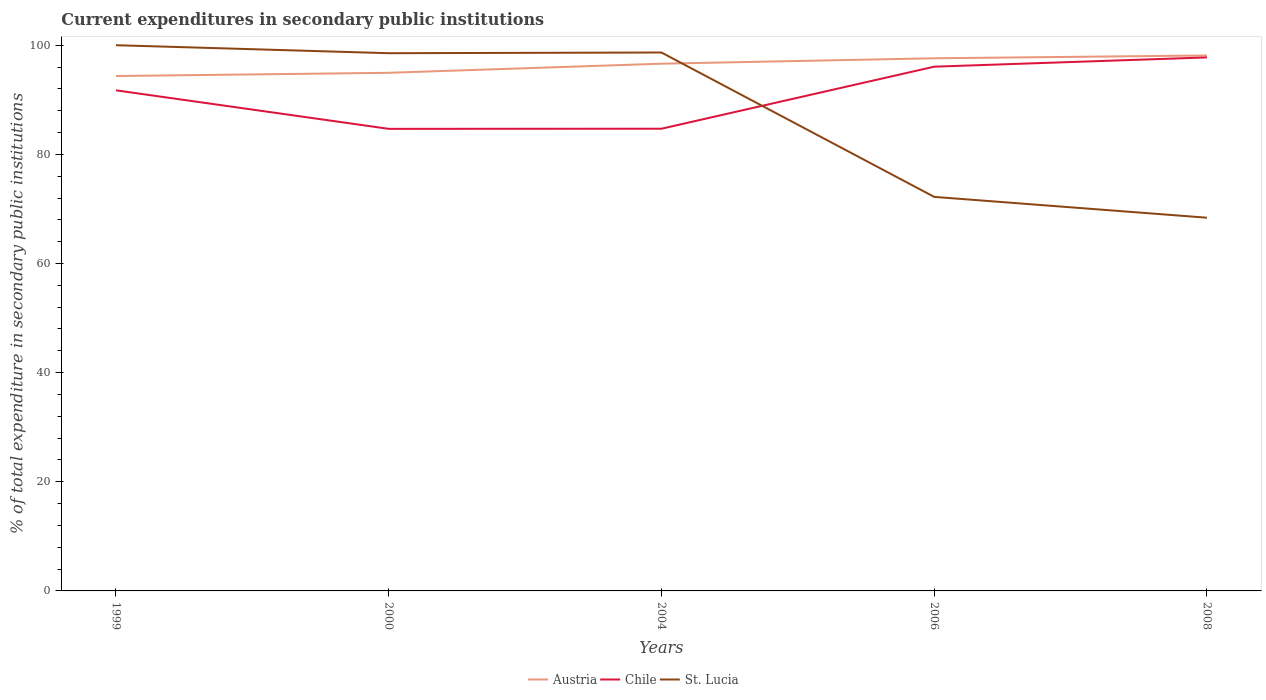How many different coloured lines are there?
Your answer should be very brief. 3. Across all years, what is the maximum current expenditures in secondary public institutions in Austria?
Provide a succinct answer. 94.35. In which year was the current expenditures in secondary public institutions in Chile maximum?
Your answer should be very brief. 2000. What is the total current expenditures in secondary public institutions in St. Lucia in the graph?
Offer a terse response. 3.82. What is the difference between the highest and the second highest current expenditures in secondary public institutions in Chile?
Your answer should be very brief. 13.09. How many lines are there?
Keep it short and to the point. 3. What is the difference between two consecutive major ticks on the Y-axis?
Your answer should be compact. 20. Does the graph contain grids?
Give a very brief answer. No. How many legend labels are there?
Offer a very short reply. 3. How are the legend labels stacked?
Offer a very short reply. Horizontal. What is the title of the graph?
Keep it short and to the point. Current expenditures in secondary public institutions. What is the label or title of the Y-axis?
Provide a short and direct response. % of total expenditure in secondary public institutions. What is the % of total expenditure in secondary public institutions of Austria in 1999?
Make the answer very short. 94.35. What is the % of total expenditure in secondary public institutions in Chile in 1999?
Keep it short and to the point. 91.73. What is the % of total expenditure in secondary public institutions of Austria in 2000?
Your answer should be compact. 94.94. What is the % of total expenditure in secondary public institutions of Chile in 2000?
Offer a terse response. 84.67. What is the % of total expenditure in secondary public institutions of St. Lucia in 2000?
Your answer should be very brief. 98.53. What is the % of total expenditure in secondary public institutions in Austria in 2004?
Offer a very short reply. 96.61. What is the % of total expenditure in secondary public institutions in Chile in 2004?
Offer a very short reply. 84.69. What is the % of total expenditure in secondary public institutions of St. Lucia in 2004?
Your answer should be very brief. 98.66. What is the % of total expenditure in secondary public institutions of Austria in 2006?
Offer a very short reply. 97.6. What is the % of total expenditure in secondary public institutions of Chile in 2006?
Offer a terse response. 96.07. What is the % of total expenditure in secondary public institutions in St. Lucia in 2006?
Ensure brevity in your answer.  72.2. What is the % of total expenditure in secondary public institutions in Austria in 2008?
Offer a terse response. 98.12. What is the % of total expenditure in secondary public institutions in Chile in 2008?
Your response must be concise. 97.76. What is the % of total expenditure in secondary public institutions in St. Lucia in 2008?
Keep it short and to the point. 68.39. Across all years, what is the maximum % of total expenditure in secondary public institutions in Austria?
Provide a short and direct response. 98.12. Across all years, what is the maximum % of total expenditure in secondary public institutions in Chile?
Your answer should be compact. 97.76. Across all years, what is the minimum % of total expenditure in secondary public institutions in Austria?
Provide a short and direct response. 94.35. Across all years, what is the minimum % of total expenditure in secondary public institutions in Chile?
Your response must be concise. 84.67. Across all years, what is the minimum % of total expenditure in secondary public institutions of St. Lucia?
Offer a very short reply. 68.39. What is the total % of total expenditure in secondary public institutions of Austria in the graph?
Your answer should be very brief. 481.63. What is the total % of total expenditure in secondary public institutions in Chile in the graph?
Offer a terse response. 454.93. What is the total % of total expenditure in secondary public institutions of St. Lucia in the graph?
Your answer should be compact. 437.79. What is the difference between the % of total expenditure in secondary public institutions of Austria in 1999 and that in 2000?
Your answer should be very brief. -0.59. What is the difference between the % of total expenditure in secondary public institutions of Chile in 1999 and that in 2000?
Give a very brief answer. 7.06. What is the difference between the % of total expenditure in secondary public institutions of St. Lucia in 1999 and that in 2000?
Offer a terse response. 1.47. What is the difference between the % of total expenditure in secondary public institutions in Austria in 1999 and that in 2004?
Offer a terse response. -2.26. What is the difference between the % of total expenditure in secondary public institutions in Chile in 1999 and that in 2004?
Provide a succinct answer. 7.04. What is the difference between the % of total expenditure in secondary public institutions of St. Lucia in 1999 and that in 2004?
Your response must be concise. 1.34. What is the difference between the % of total expenditure in secondary public institutions in Austria in 1999 and that in 2006?
Provide a short and direct response. -3.25. What is the difference between the % of total expenditure in secondary public institutions of Chile in 1999 and that in 2006?
Offer a terse response. -4.33. What is the difference between the % of total expenditure in secondary public institutions in St. Lucia in 1999 and that in 2006?
Offer a terse response. 27.8. What is the difference between the % of total expenditure in secondary public institutions of Austria in 1999 and that in 2008?
Offer a terse response. -3.77. What is the difference between the % of total expenditure in secondary public institutions of Chile in 1999 and that in 2008?
Your answer should be compact. -6.03. What is the difference between the % of total expenditure in secondary public institutions in St. Lucia in 1999 and that in 2008?
Keep it short and to the point. 31.61. What is the difference between the % of total expenditure in secondary public institutions in Austria in 2000 and that in 2004?
Make the answer very short. -1.67. What is the difference between the % of total expenditure in secondary public institutions of Chile in 2000 and that in 2004?
Your response must be concise. -0.02. What is the difference between the % of total expenditure in secondary public institutions in St. Lucia in 2000 and that in 2004?
Offer a very short reply. -0.13. What is the difference between the % of total expenditure in secondary public institutions in Austria in 2000 and that in 2006?
Your response must be concise. -2.66. What is the difference between the % of total expenditure in secondary public institutions of Chile in 2000 and that in 2006?
Give a very brief answer. -11.39. What is the difference between the % of total expenditure in secondary public institutions in St. Lucia in 2000 and that in 2006?
Keep it short and to the point. 26.33. What is the difference between the % of total expenditure in secondary public institutions in Austria in 2000 and that in 2008?
Your answer should be very brief. -3.17. What is the difference between the % of total expenditure in secondary public institutions of Chile in 2000 and that in 2008?
Offer a terse response. -13.09. What is the difference between the % of total expenditure in secondary public institutions in St. Lucia in 2000 and that in 2008?
Keep it short and to the point. 30.14. What is the difference between the % of total expenditure in secondary public institutions of Austria in 2004 and that in 2006?
Your answer should be compact. -0.99. What is the difference between the % of total expenditure in secondary public institutions in Chile in 2004 and that in 2006?
Your answer should be compact. -11.37. What is the difference between the % of total expenditure in secondary public institutions of St. Lucia in 2004 and that in 2006?
Keep it short and to the point. 26.46. What is the difference between the % of total expenditure in secondary public institutions of Austria in 2004 and that in 2008?
Offer a terse response. -1.51. What is the difference between the % of total expenditure in secondary public institutions of Chile in 2004 and that in 2008?
Your answer should be very brief. -13.07. What is the difference between the % of total expenditure in secondary public institutions in St. Lucia in 2004 and that in 2008?
Ensure brevity in your answer.  30.27. What is the difference between the % of total expenditure in secondary public institutions of Austria in 2006 and that in 2008?
Provide a succinct answer. -0.51. What is the difference between the % of total expenditure in secondary public institutions in Chile in 2006 and that in 2008?
Your response must be concise. -1.7. What is the difference between the % of total expenditure in secondary public institutions in St. Lucia in 2006 and that in 2008?
Your answer should be compact. 3.82. What is the difference between the % of total expenditure in secondary public institutions in Austria in 1999 and the % of total expenditure in secondary public institutions in Chile in 2000?
Your response must be concise. 9.68. What is the difference between the % of total expenditure in secondary public institutions in Austria in 1999 and the % of total expenditure in secondary public institutions in St. Lucia in 2000?
Your answer should be compact. -4.18. What is the difference between the % of total expenditure in secondary public institutions of Chile in 1999 and the % of total expenditure in secondary public institutions of St. Lucia in 2000?
Provide a succinct answer. -6.8. What is the difference between the % of total expenditure in secondary public institutions in Austria in 1999 and the % of total expenditure in secondary public institutions in Chile in 2004?
Ensure brevity in your answer.  9.66. What is the difference between the % of total expenditure in secondary public institutions of Austria in 1999 and the % of total expenditure in secondary public institutions of St. Lucia in 2004?
Provide a short and direct response. -4.31. What is the difference between the % of total expenditure in secondary public institutions of Chile in 1999 and the % of total expenditure in secondary public institutions of St. Lucia in 2004?
Make the answer very short. -6.93. What is the difference between the % of total expenditure in secondary public institutions in Austria in 1999 and the % of total expenditure in secondary public institutions in Chile in 2006?
Provide a succinct answer. -1.71. What is the difference between the % of total expenditure in secondary public institutions of Austria in 1999 and the % of total expenditure in secondary public institutions of St. Lucia in 2006?
Your response must be concise. 22.15. What is the difference between the % of total expenditure in secondary public institutions of Chile in 1999 and the % of total expenditure in secondary public institutions of St. Lucia in 2006?
Ensure brevity in your answer.  19.53. What is the difference between the % of total expenditure in secondary public institutions of Austria in 1999 and the % of total expenditure in secondary public institutions of Chile in 2008?
Make the answer very short. -3.41. What is the difference between the % of total expenditure in secondary public institutions in Austria in 1999 and the % of total expenditure in secondary public institutions in St. Lucia in 2008?
Offer a terse response. 25.96. What is the difference between the % of total expenditure in secondary public institutions in Chile in 1999 and the % of total expenditure in secondary public institutions in St. Lucia in 2008?
Your answer should be compact. 23.34. What is the difference between the % of total expenditure in secondary public institutions in Austria in 2000 and the % of total expenditure in secondary public institutions in Chile in 2004?
Ensure brevity in your answer.  10.25. What is the difference between the % of total expenditure in secondary public institutions in Austria in 2000 and the % of total expenditure in secondary public institutions in St. Lucia in 2004?
Provide a short and direct response. -3.72. What is the difference between the % of total expenditure in secondary public institutions of Chile in 2000 and the % of total expenditure in secondary public institutions of St. Lucia in 2004?
Provide a succinct answer. -13.99. What is the difference between the % of total expenditure in secondary public institutions in Austria in 2000 and the % of total expenditure in secondary public institutions in Chile in 2006?
Provide a short and direct response. -1.12. What is the difference between the % of total expenditure in secondary public institutions in Austria in 2000 and the % of total expenditure in secondary public institutions in St. Lucia in 2006?
Offer a terse response. 22.74. What is the difference between the % of total expenditure in secondary public institutions in Chile in 2000 and the % of total expenditure in secondary public institutions in St. Lucia in 2006?
Your response must be concise. 12.47. What is the difference between the % of total expenditure in secondary public institutions of Austria in 2000 and the % of total expenditure in secondary public institutions of Chile in 2008?
Provide a succinct answer. -2.82. What is the difference between the % of total expenditure in secondary public institutions in Austria in 2000 and the % of total expenditure in secondary public institutions in St. Lucia in 2008?
Your answer should be very brief. 26.55. What is the difference between the % of total expenditure in secondary public institutions in Chile in 2000 and the % of total expenditure in secondary public institutions in St. Lucia in 2008?
Ensure brevity in your answer.  16.29. What is the difference between the % of total expenditure in secondary public institutions in Austria in 2004 and the % of total expenditure in secondary public institutions in Chile in 2006?
Your response must be concise. 0.55. What is the difference between the % of total expenditure in secondary public institutions of Austria in 2004 and the % of total expenditure in secondary public institutions of St. Lucia in 2006?
Your answer should be compact. 24.41. What is the difference between the % of total expenditure in secondary public institutions of Chile in 2004 and the % of total expenditure in secondary public institutions of St. Lucia in 2006?
Your response must be concise. 12.49. What is the difference between the % of total expenditure in secondary public institutions in Austria in 2004 and the % of total expenditure in secondary public institutions in Chile in 2008?
Your response must be concise. -1.15. What is the difference between the % of total expenditure in secondary public institutions in Austria in 2004 and the % of total expenditure in secondary public institutions in St. Lucia in 2008?
Your response must be concise. 28.22. What is the difference between the % of total expenditure in secondary public institutions in Chile in 2004 and the % of total expenditure in secondary public institutions in St. Lucia in 2008?
Give a very brief answer. 16.31. What is the difference between the % of total expenditure in secondary public institutions in Austria in 2006 and the % of total expenditure in secondary public institutions in Chile in 2008?
Keep it short and to the point. -0.16. What is the difference between the % of total expenditure in secondary public institutions of Austria in 2006 and the % of total expenditure in secondary public institutions of St. Lucia in 2008?
Ensure brevity in your answer.  29.22. What is the difference between the % of total expenditure in secondary public institutions of Chile in 2006 and the % of total expenditure in secondary public institutions of St. Lucia in 2008?
Your answer should be very brief. 27.68. What is the average % of total expenditure in secondary public institutions in Austria per year?
Offer a terse response. 96.33. What is the average % of total expenditure in secondary public institutions in Chile per year?
Give a very brief answer. 90.99. What is the average % of total expenditure in secondary public institutions in St. Lucia per year?
Offer a terse response. 87.56. In the year 1999, what is the difference between the % of total expenditure in secondary public institutions of Austria and % of total expenditure in secondary public institutions of Chile?
Offer a very short reply. 2.62. In the year 1999, what is the difference between the % of total expenditure in secondary public institutions in Austria and % of total expenditure in secondary public institutions in St. Lucia?
Provide a succinct answer. -5.65. In the year 1999, what is the difference between the % of total expenditure in secondary public institutions of Chile and % of total expenditure in secondary public institutions of St. Lucia?
Offer a terse response. -8.27. In the year 2000, what is the difference between the % of total expenditure in secondary public institutions of Austria and % of total expenditure in secondary public institutions of Chile?
Offer a very short reply. 10.27. In the year 2000, what is the difference between the % of total expenditure in secondary public institutions in Austria and % of total expenditure in secondary public institutions in St. Lucia?
Provide a short and direct response. -3.59. In the year 2000, what is the difference between the % of total expenditure in secondary public institutions of Chile and % of total expenditure in secondary public institutions of St. Lucia?
Give a very brief answer. -13.86. In the year 2004, what is the difference between the % of total expenditure in secondary public institutions in Austria and % of total expenditure in secondary public institutions in Chile?
Ensure brevity in your answer.  11.92. In the year 2004, what is the difference between the % of total expenditure in secondary public institutions in Austria and % of total expenditure in secondary public institutions in St. Lucia?
Give a very brief answer. -2.05. In the year 2004, what is the difference between the % of total expenditure in secondary public institutions in Chile and % of total expenditure in secondary public institutions in St. Lucia?
Provide a succinct answer. -13.97. In the year 2006, what is the difference between the % of total expenditure in secondary public institutions of Austria and % of total expenditure in secondary public institutions of Chile?
Provide a succinct answer. 1.54. In the year 2006, what is the difference between the % of total expenditure in secondary public institutions in Austria and % of total expenditure in secondary public institutions in St. Lucia?
Provide a succinct answer. 25.4. In the year 2006, what is the difference between the % of total expenditure in secondary public institutions in Chile and % of total expenditure in secondary public institutions in St. Lucia?
Ensure brevity in your answer.  23.86. In the year 2008, what is the difference between the % of total expenditure in secondary public institutions in Austria and % of total expenditure in secondary public institutions in Chile?
Keep it short and to the point. 0.35. In the year 2008, what is the difference between the % of total expenditure in secondary public institutions in Austria and % of total expenditure in secondary public institutions in St. Lucia?
Ensure brevity in your answer.  29.73. In the year 2008, what is the difference between the % of total expenditure in secondary public institutions of Chile and % of total expenditure in secondary public institutions of St. Lucia?
Your answer should be compact. 29.37. What is the ratio of the % of total expenditure in secondary public institutions in Chile in 1999 to that in 2000?
Ensure brevity in your answer.  1.08. What is the ratio of the % of total expenditure in secondary public institutions in St. Lucia in 1999 to that in 2000?
Offer a terse response. 1.01. What is the ratio of the % of total expenditure in secondary public institutions of Austria in 1999 to that in 2004?
Offer a terse response. 0.98. What is the ratio of the % of total expenditure in secondary public institutions in Chile in 1999 to that in 2004?
Provide a succinct answer. 1.08. What is the ratio of the % of total expenditure in secondary public institutions of St. Lucia in 1999 to that in 2004?
Your answer should be very brief. 1.01. What is the ratio of the % of total expenditure in secondary public institutions in Austria in 1999 to that in 2006?
Ensure brevity in your answer.  0.97. What is the ratio of the % of total expenditure in secondary public institutions of Chile in 1999 to that in 2006?
Your response must be concise. 0.95. What is the ratio of the % of total expenditure in secondary public institutions of St. Lucia in 1999 to that in 2006?
Ensure brevity in your answer.  1.39. What is the ratio of the % of total expenditure in secondary public institutions in Austria in 1999 to that in 2008?
Your answer should be compact. 0.96. What is the ratio of the % of total expenditure in secondary public institutions of Chile in 1999 to that in 2008?
Offer a very short reply. 0.94. What is the ratio of the % of total expenditure in secondary public institutions of St. Lucia in 1999 to that in 2008?
Your answer should be very brief. 1.46. What is the ratio of the % of total expenditure in secondary public institutions of Austria in 2000 to that in 2004?
Keep it short and to the point. 0.98. What is the ratio of the % of total expenditure in secondary public institutions of St. Lucia in 2000 to that in 2004?
Your answer should be compact. 1. What is the ratio of the % of total expenditure in secondary public institutions of Austria in 2000 to that in 2006?
Your answer should be very brief. 0.97. What is the ratio of the % of total expenditure in secondary public institutions in Chile in 2000 to that in 2006?
Your answer should be very brief. 0.88. What is the ratio of the % of total expenditure in secondary public institutions of St. Lucia in 2000 to that in 2006?
Your answer should be very brief. 1.36. What is the ratio of the % of total expenditure in secondary public institutions in Austria in 2000 to that in 2008?
Give a very brief answer. 0.97. What is the ratio of the % of total expenditure in secondary public institutions of Chile in 2000 to that in 2008?
Keep it short and to the point. 0.87. What is the ratio of the % of total expenditure in secondary public institutions of St. Lucia in 2000 to that in 2008?
Your answer should be compact. 1.44. What is the ratio of the % of total expenditure in secondary public institutions of Chile in 2004 to that in 2006?
Offer a terse response. 0.88. What is the ratio of the % of total expenditure in secondary public institutions in St. Lucia in 2004 to that in 2006?
Ensure brevity in your answer.  1.37. What is the ratio of the % of total expenditure in secondary public institutions of Austria in 2004 to that in 2008?
Your response must be concise. 0.98. What is the ratio of the % of total expenditure in secondary public institutions of Chile in 2004 to that in 2008?
Offer a very short reply. 0.87. What is the ratio of the % of total expenditure in secondary public institutions in St. Lucia in 2004 to that in 2008?
Your response must be concise. 1.44. What is the ratio of the % of total expenditure in secondary public institutions of Austria in 2006 to that in 2008?
Keep it short and to the point. 0.99. What is the ratio of the % of total expenditure in secondary public institutions in Chile in 2006 to that in 2008?
Offer a very short reply. 0.98. What is the ratio of the % of total expenditure in secondary public institutions of St. Lucia in 2006 to that in 2008?
Your answer should be compact. 1.06. What is the difference between the highest and the second highest % of total expenditure in secondary public institutions of Austria?
Give a very brief answer. 0.51. What is the difference between the highest and the second highest % of total expenditure in secondary public institutions in Chile?
Make the answer very short. 1.7. What is the difference between the highest and the second highest % of total expenditure in secondary public institutions of St. Lucia?
Your answer should be very brief. 1.34. What is the difference between the highest and the lowest % of total expenditure in secondary public institutions of Austria?
Ensure brevity in your answer.  3.77. What is the difference between the highest and the lowest % of total expenditure in secondary public institutions of Chile?
Ensure brevity in your answer.  13.09. What is the difference between the highest and the lowest % of total expenditure in secondary public institutions in St. Lucia?
Offer a terse response. 31.61. 